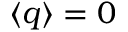Convert formula to latex. <formula><loc_0><loc_0><loc_500><loc_500>\langle q \rangle = 0</formula> 